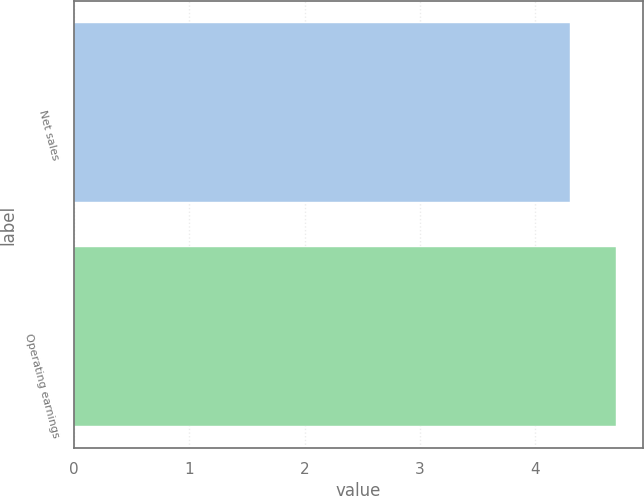<chart> <loc_0><loc_0><loc_500><loc_500><bar_chart><fcel>Net sales<fcel>Operating earnings<nl><fcel>4.3<fcel>4.7<nl></chart> 